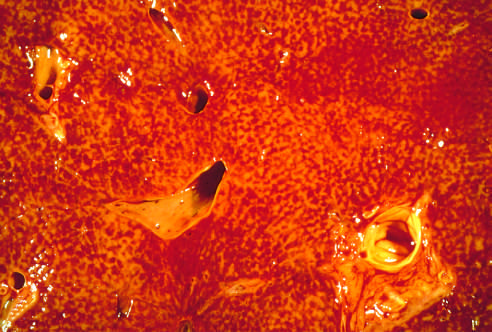re carcinoid tumors visible?
Answer the question using a single word or phrase. No 